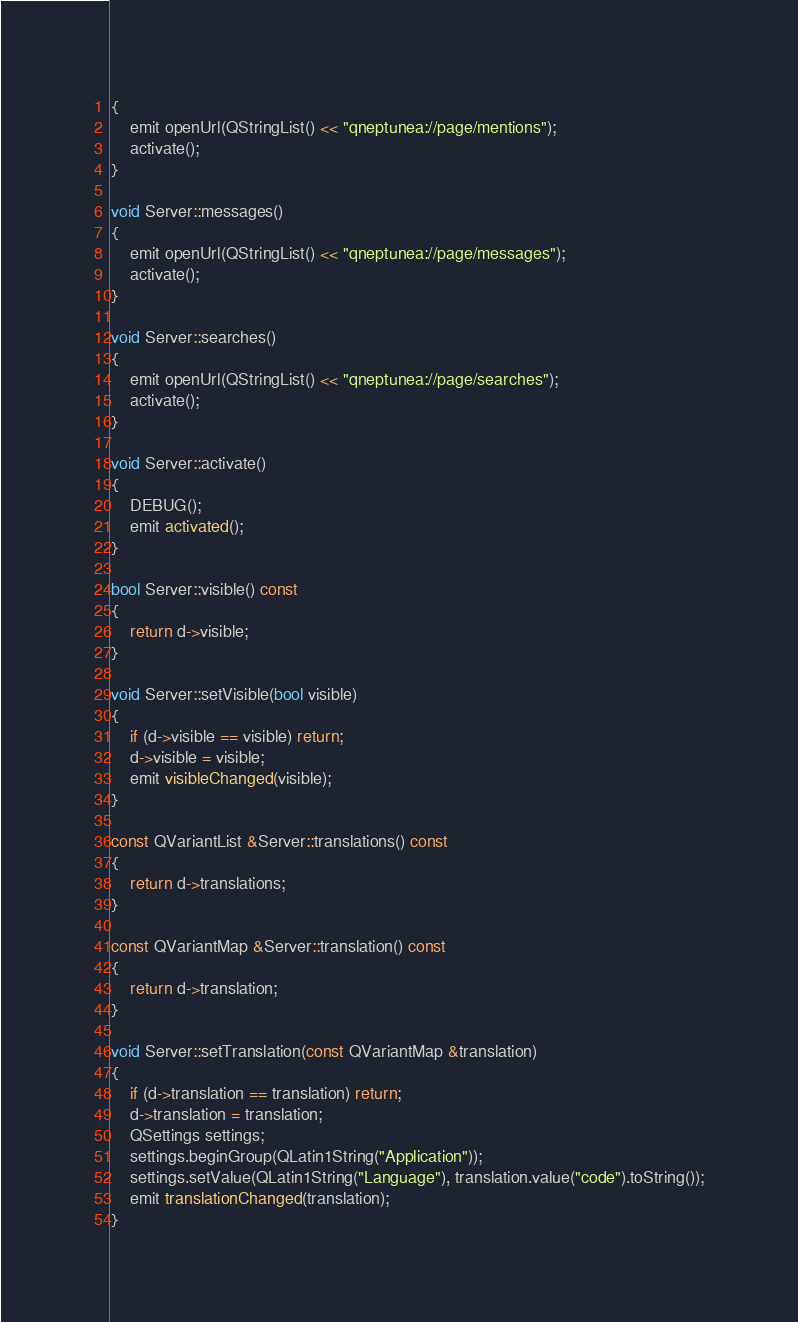Convert code to text. <code><loc_0><loc_0><loc_500><loc_500><_C++_>{
    emit openUrl(QStringList() << "qneptunea://page/mentions");
    activate();
}

void Server::messages()
{
    emit openUrl(QStringList() << "qneptunea://page/messages");
    activate();
}

void Server::searches()
{
    emit openUrl(QStringList() << "qneptunea://page/searches");
    activate();
}

void Server::activate()
{
    DEBUG();
    emit activated();
}

bool Server::visible() const
{
    return d->visible;
}

void Server::setVisible(bool visible)
{
    if (d->visible == visible) return;
    d->visible = visible;
    emit visibleChanged(visible);
}

const QVariantList &Server::translations() const
{
    return d->translations;
}

const QVariantMap &Server::translation() const
{
    return d->translation;
}

void Server::setTranslation(const QVariantMap &translation)
{
    if (d->translation == translation) return;
    d->translation = translation;
    QSettings settings;
    settings.beginGroup(QLatin1String("Application"));
    settings.setValue(QLatin1String("Language"), translation.value("code").toString());
    emit translationChanged(translation);
}
</code> 